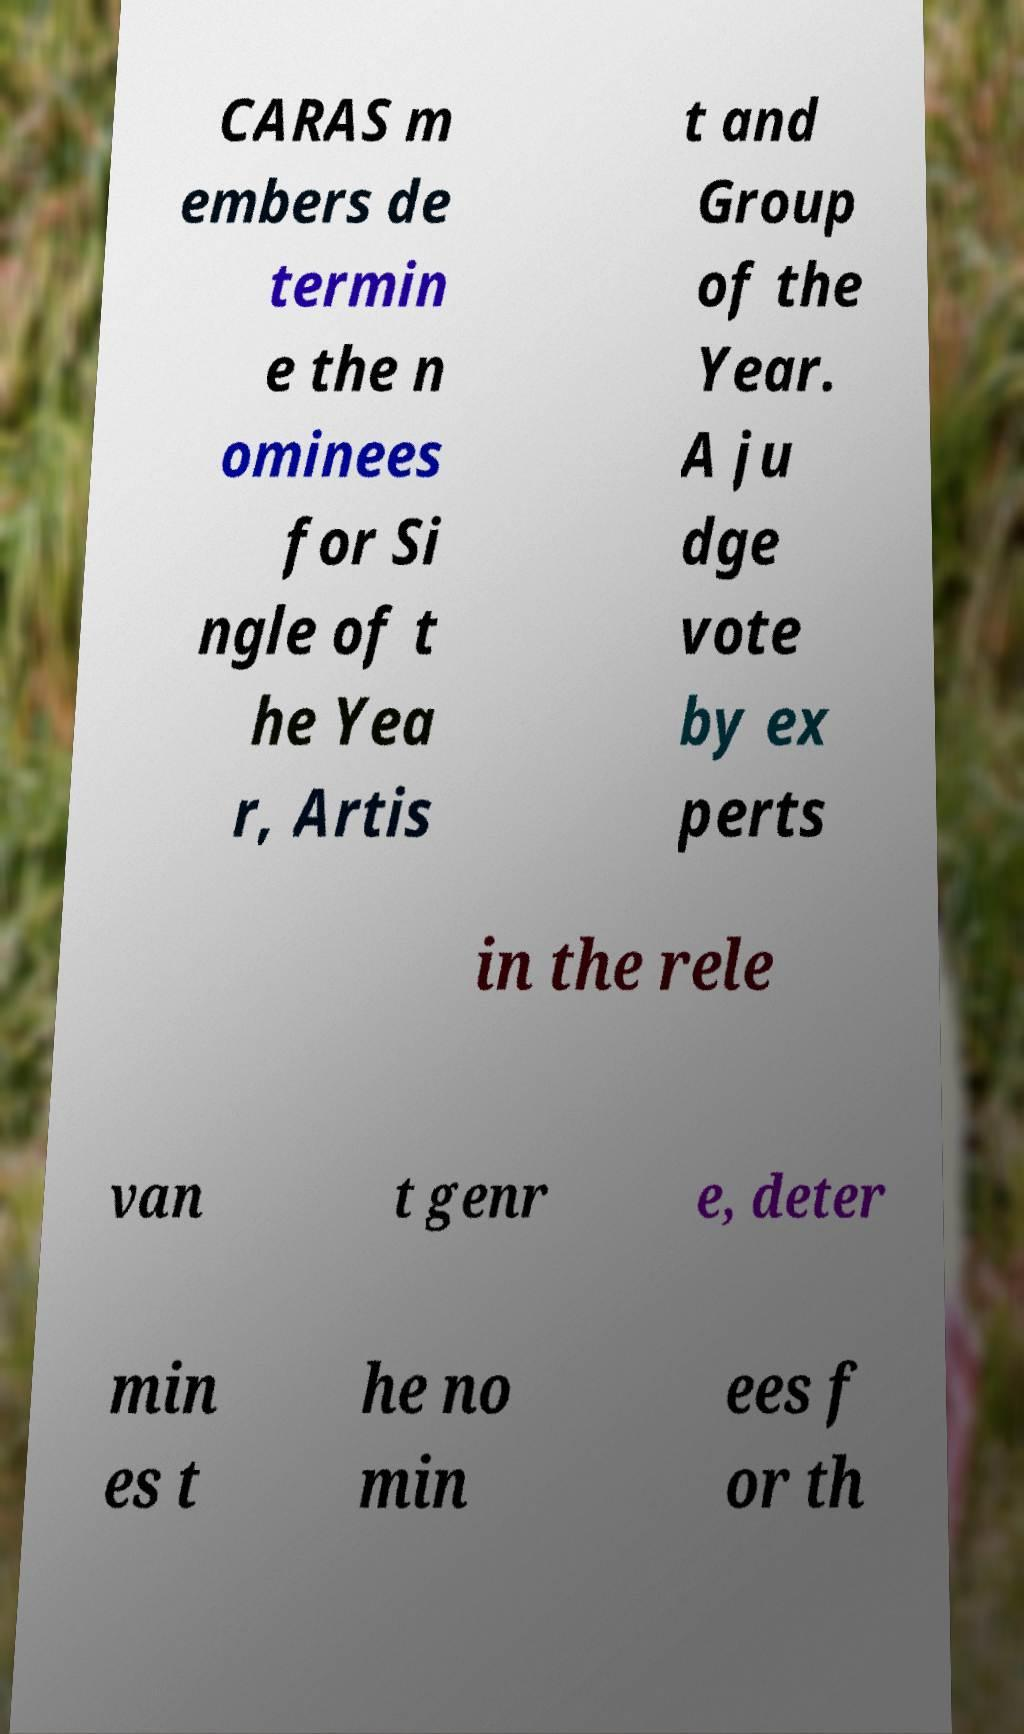There's text embedded in this image that I need extracted. Can you transcribe it verbatim? CARAS m embers de termin e the n ominees for Si ngle of t he Yea r, Artis t and Group of the Year. A ju dge vote by ex perts in the rele van t genr e, deter min es t he no min ees f or th 